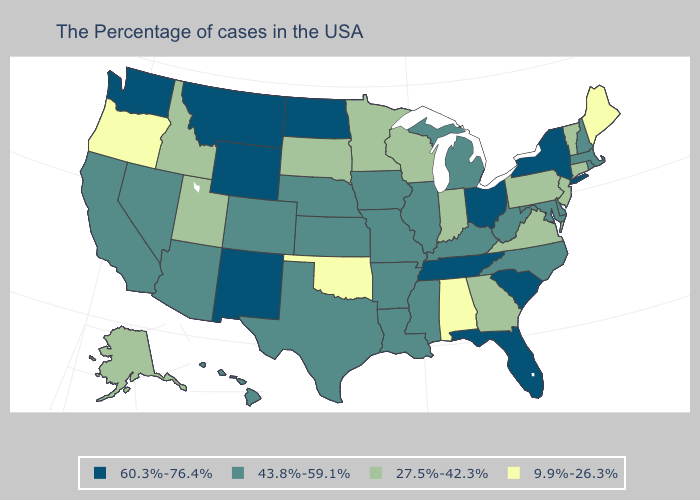What is the value of New Mexico?
Concise answer only. 60.3%-76.4%. Which states have the lowest value in the Northeast?
Short answer required. Maine. Does the map have missing data?
Write a very short answer. No. Does Montana have a higher value than South Carolina?
Concise answer only. No. Which states have the highest value in the USA?
Be succinct. New York, South Carolina, Ohio, Florida, Tennessee, North Dakota, Wyoming, New Mexico, Montana, Washington. Among the states that border New Jersey , which have the highest value?
Answer briefly. New York. What is the value of Tennessee?
Short answer required. 60.3%-76.4%. What is the value of South Carolina?
Quick response, please. 60.3%-76.4%. Does Ohio have a higher value than Nevada?
Quick response, please. Yes. What is the value of New Mexico?
Answer briefly. 60.3%-76.4%. Among the states that border North Carolina , which have the lowest value?
Write a very short answer. Virginia, Georgia. Which states hav the highest value in the MidWest?
Write a very short answer. Ohio, North Dakota. Among the states that border Alabama , which have the highest value?
Quick response, please. Florida, Tennessee. Does Nebraska have the lowest value in the USA?
Answer briefly. No. Does the map have missing data?
Concise answer only. No. 